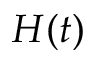Convert formula to latex. <formula><loc_0><loc_0><loc_500><loc_500>H ( t )</formula> 